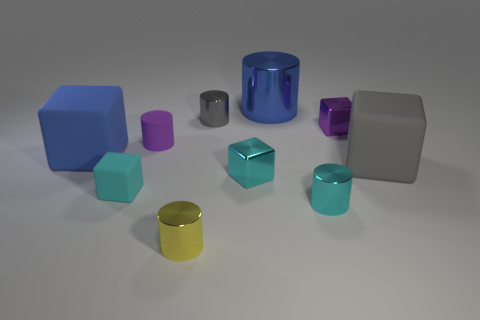How many objects are there and what are their colors? In the image, there are nine objects in total, consisting of a blue cylinder, a purple small cylinder, a teal smaller cube, a large blue cube, a small pink cube, a yellow cylinder, a gray cube, a teal large cylinder, and a smaller gray shiny cylinder. 